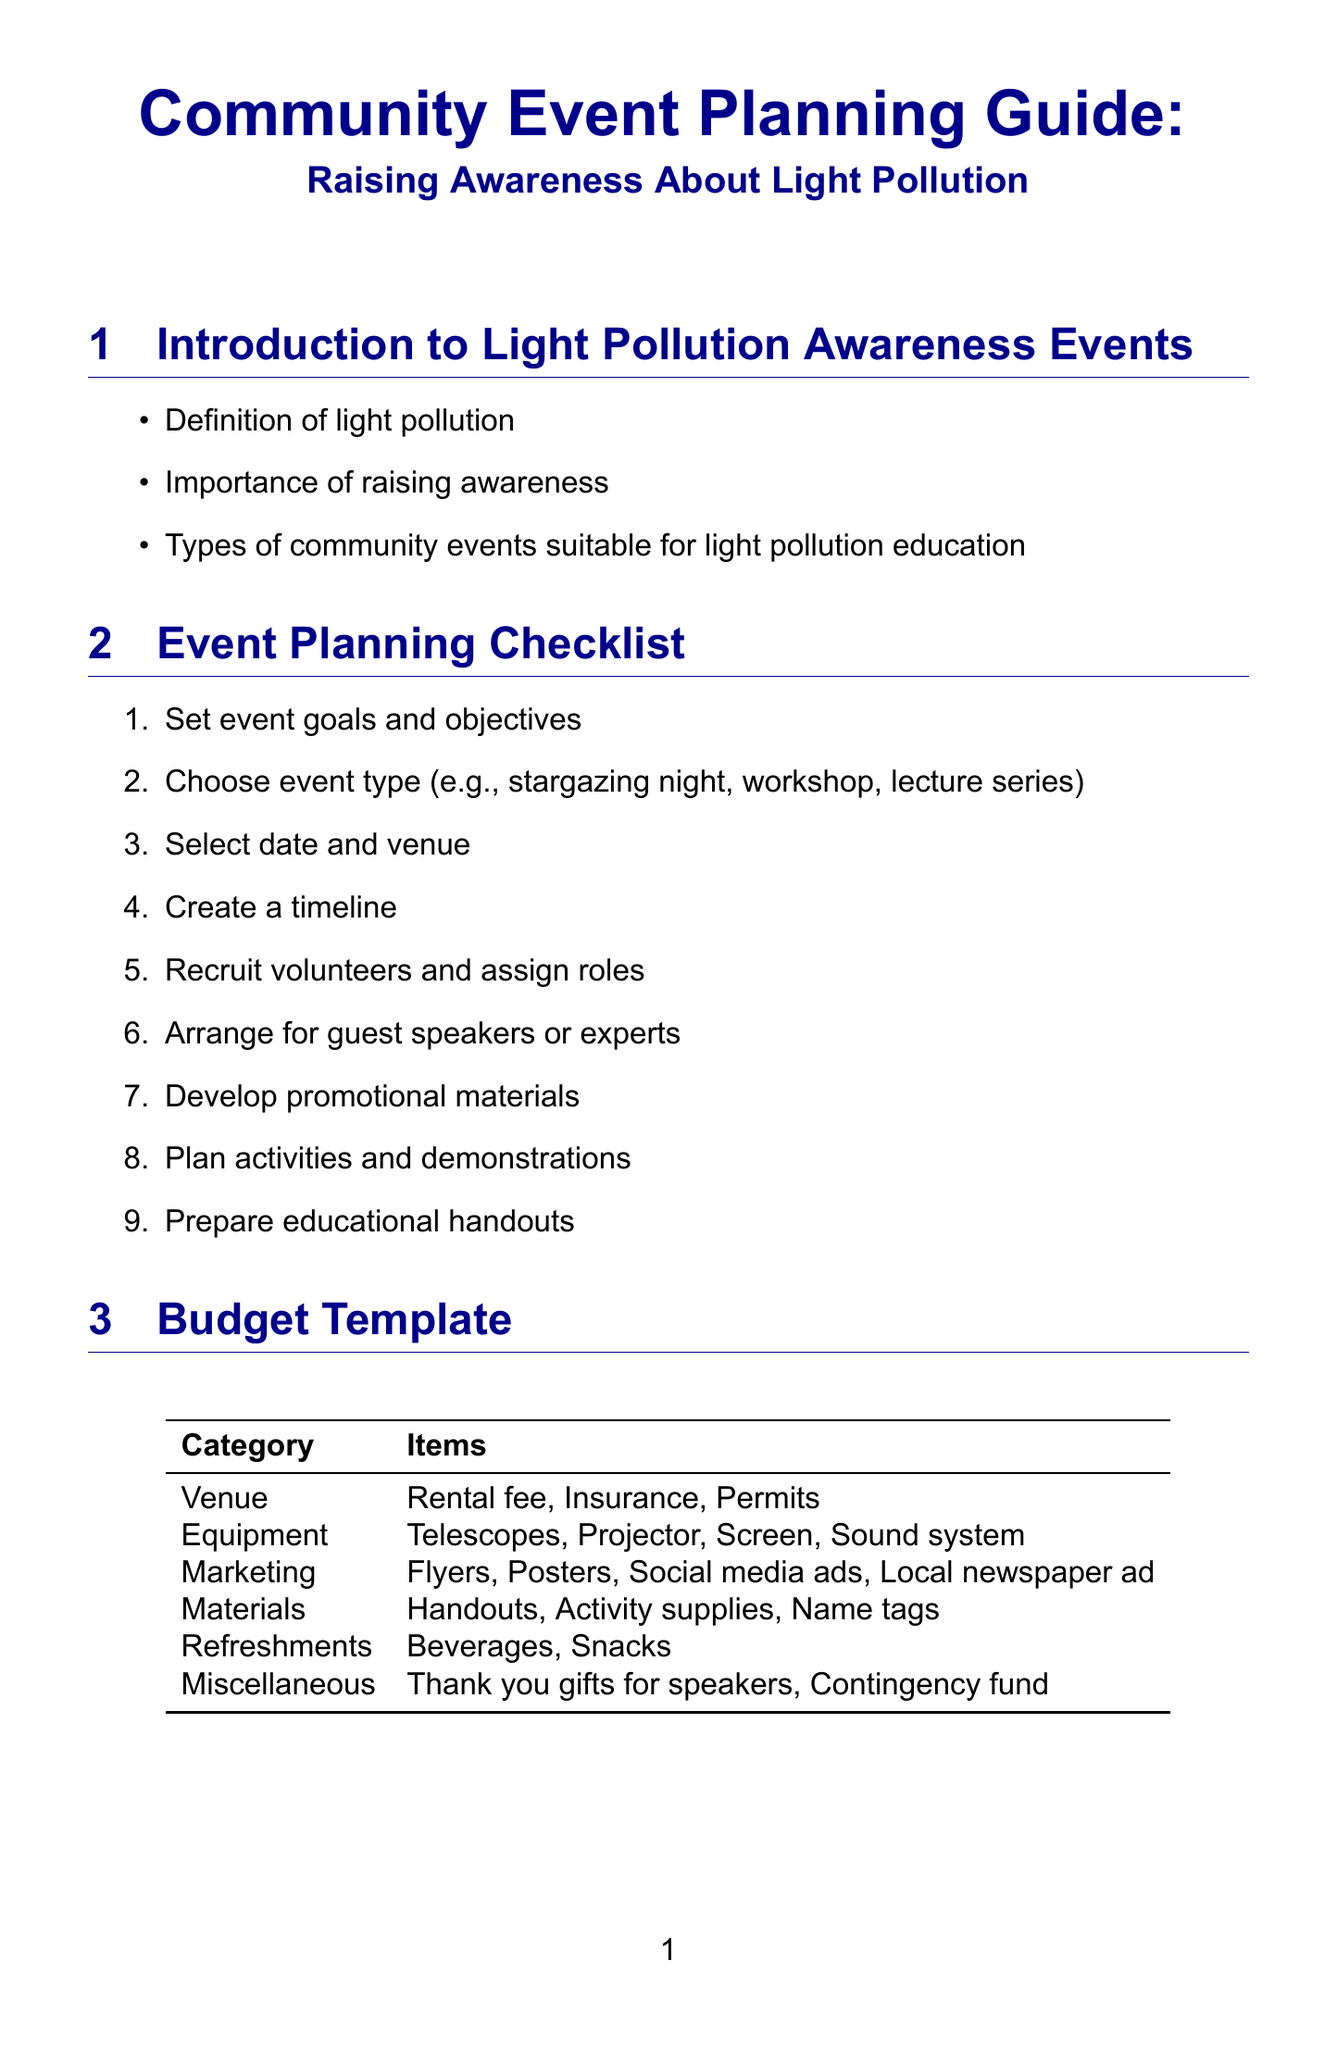What are the types of events suitable for light pollution education? The document lists types of community events that can educate about light pollution, including stargazing nights, workshops, and lecture series.
Answer: Stargazing night, workshop, lecture series What is one of the effects of light pollution mentioned? The document states several effects of light pollution, including its impact on wildlife, human health, and ecosystems.
Answer: Effects on wildlife and ecosystems What is included in the budget template under "Equipment"? The budget template lists specific items needed for the event under various categories. For "Equipment," it includes telescopes, a projector, a screen, and a sound system.
Answer: Telescopes, projector, screen, sound system How many interactive activities are listed? The document enumerates interactive activities for attendees, with a total of five activities.
Answer: Five What is a suggested strategy for promoting the event? The promotion section mentions various strategies, one being the creation of an event hashtag.
Answer: Create event hashtag What type of organizations are suggested for collaboration? The manual suggests several types of organizations for partnerships, including local astronomy clubs and environmental organizations.
Answer: Local astronomy clubs, environmental organizations What should be prepared as part of the event planning checklist? The checklist outlines steps to prepare for the event, including developing promotional materials and preparing educational handouts.
Answer: Develop promotional materials, prepare educational handouts Which website is recommended for further reading? The resources section lists several valuable websites for additional information about light pollution awareness.
Answer: International Dark-Sky Association website What is an example of a post-event evaluation method? The document suggests several techniques for post-event evaluation, including gathering attendee feedback through surveys.
Answer: Attendee feedback survey 